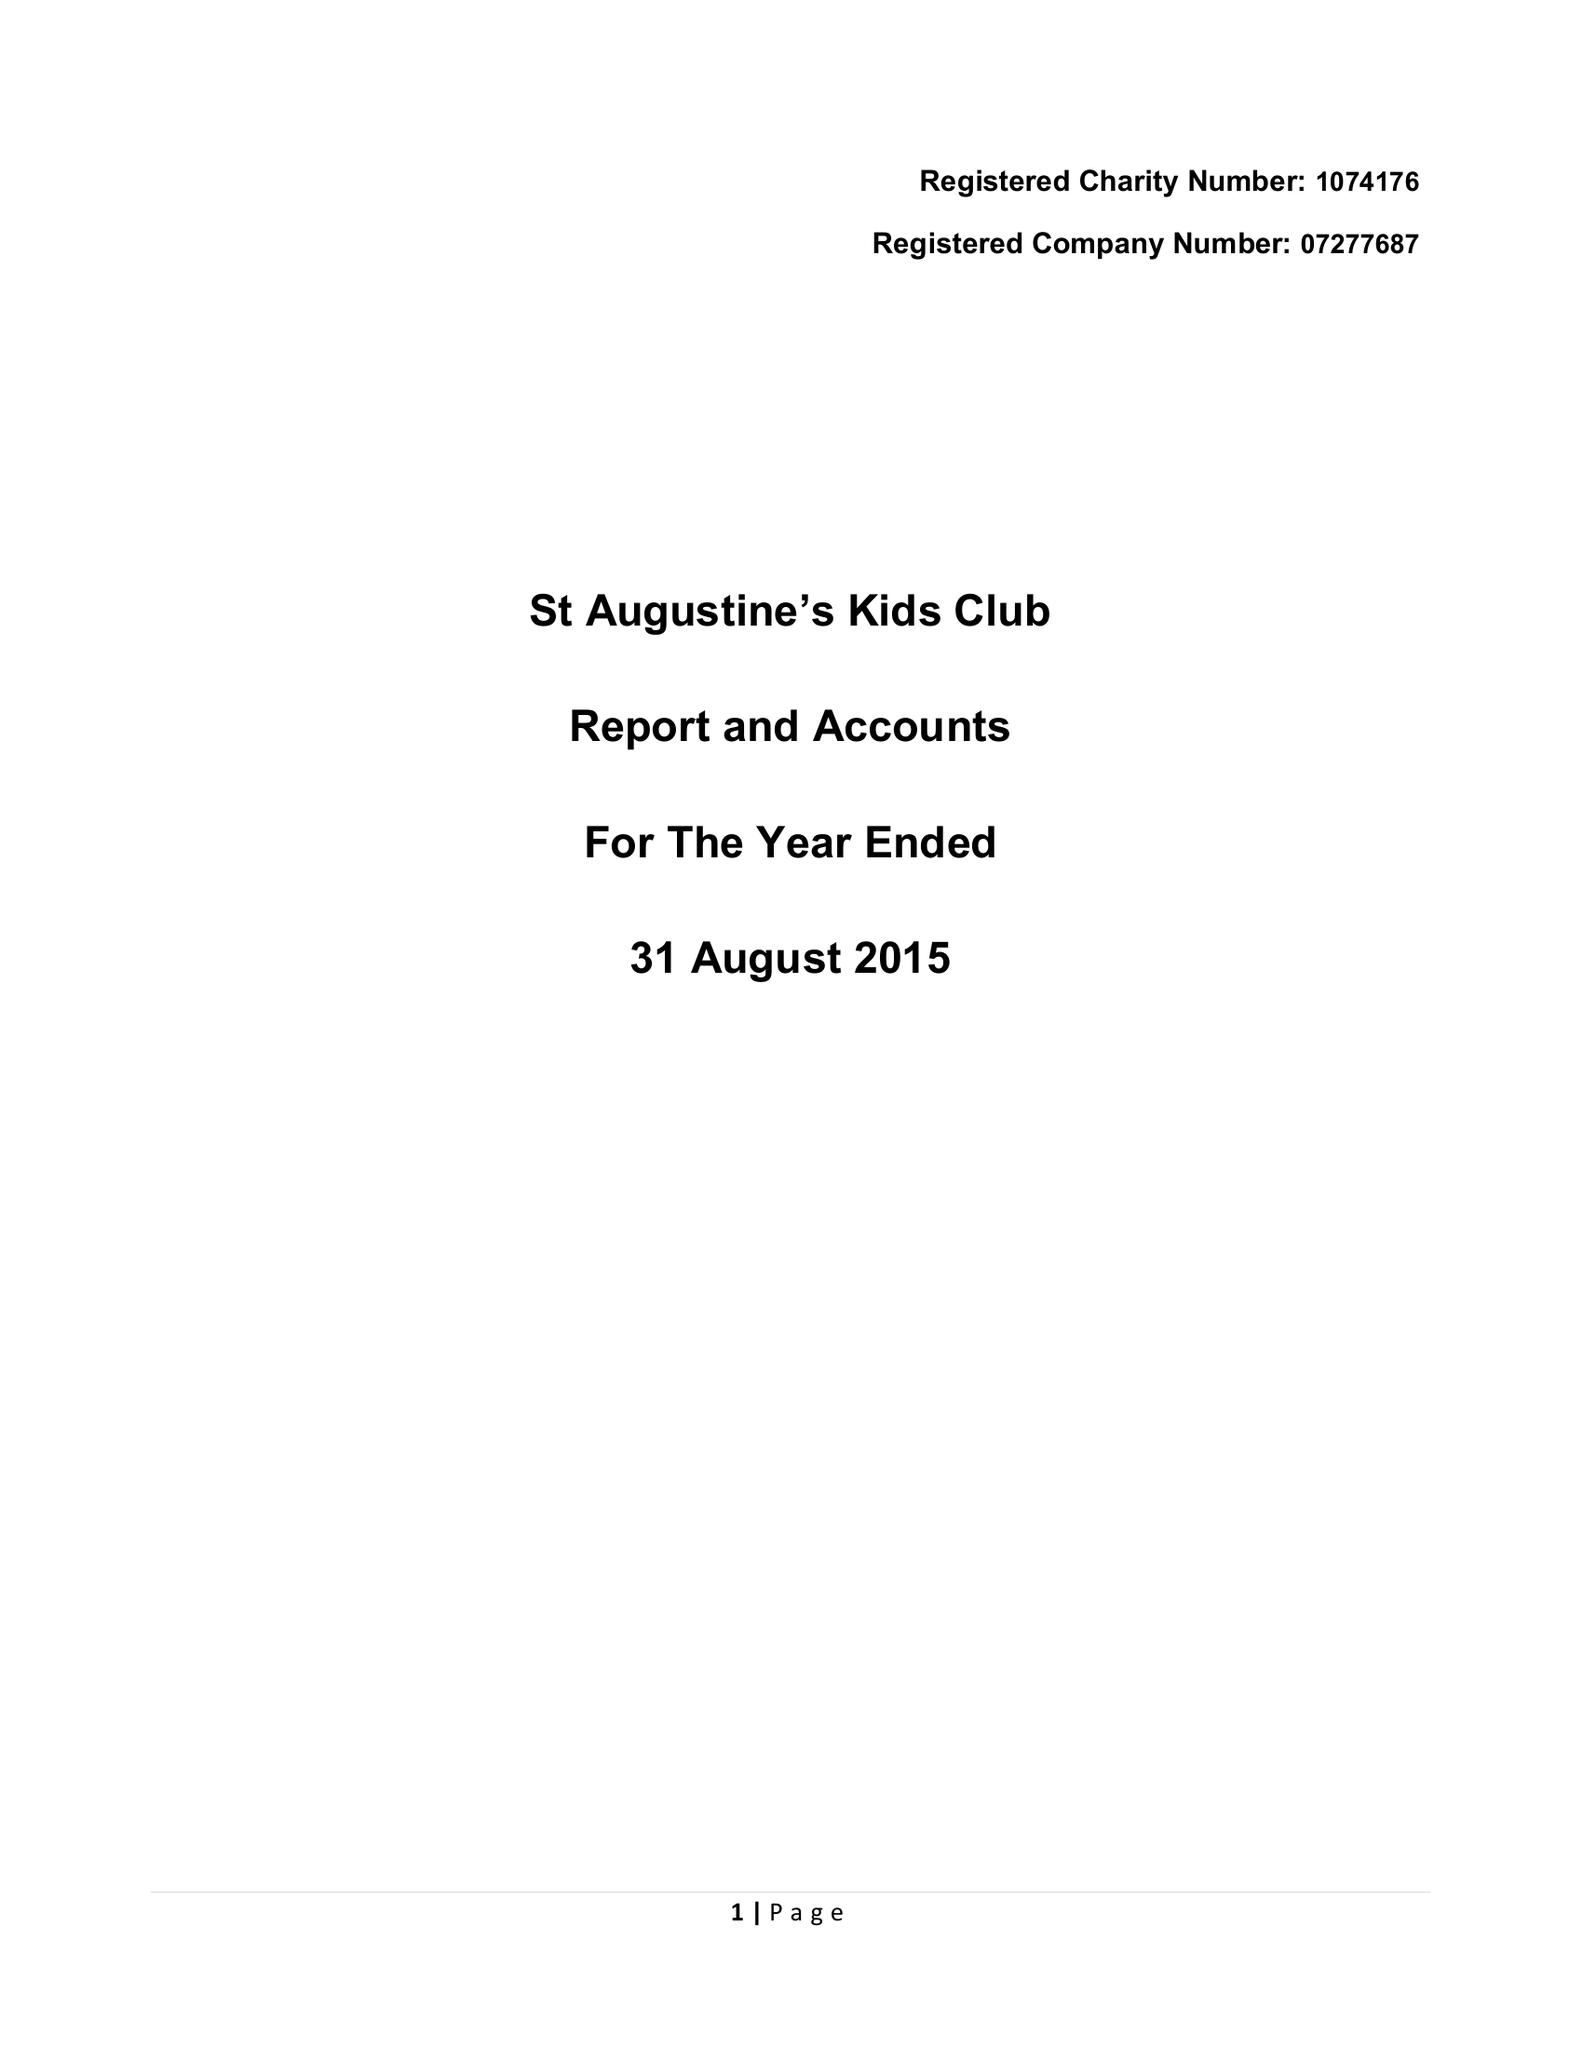What is the value for the address__postcode?
Answer the question using a single word or phrase. CV8 2JY 